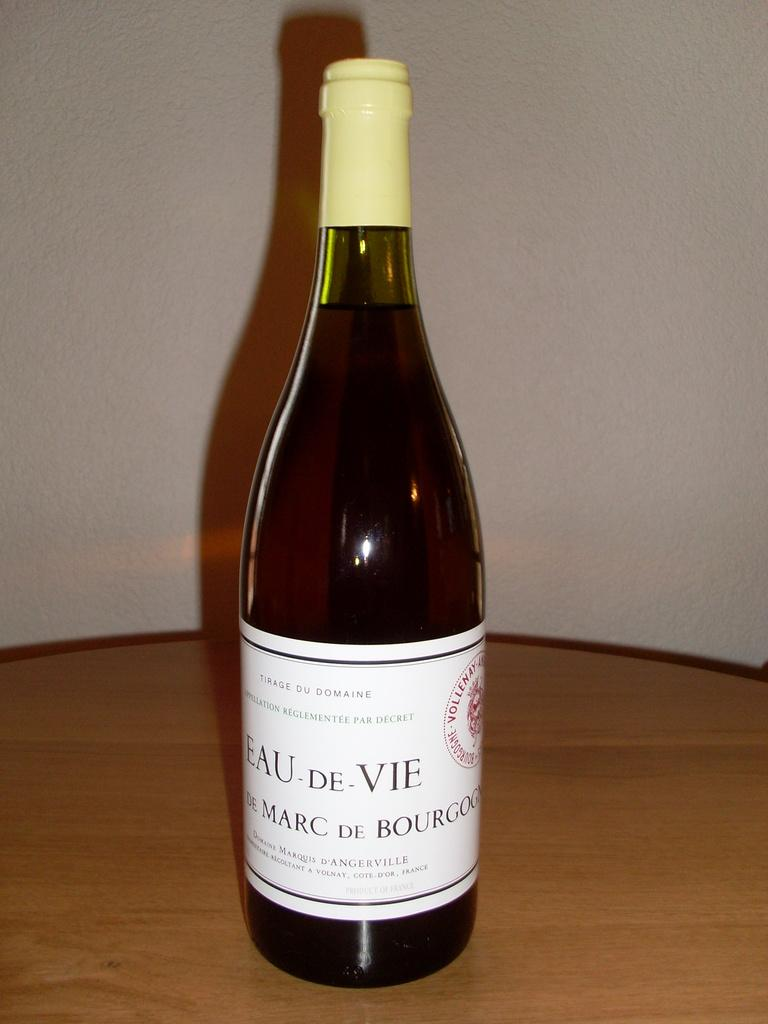Provide a one-sentence caption for the provided image. A bottle of Eau De Vie sits on the table in a bottle. 